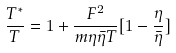<formula> <loc_0><loc_0><loc_500><loc_500>\frac { T ^ { * } } { T } = 1 + \frac { F ^ { 2 } } { m \eta \bar { \eta } T } [ 1 - \frac { \eta } { \bar { \eta } } ]</formula> 